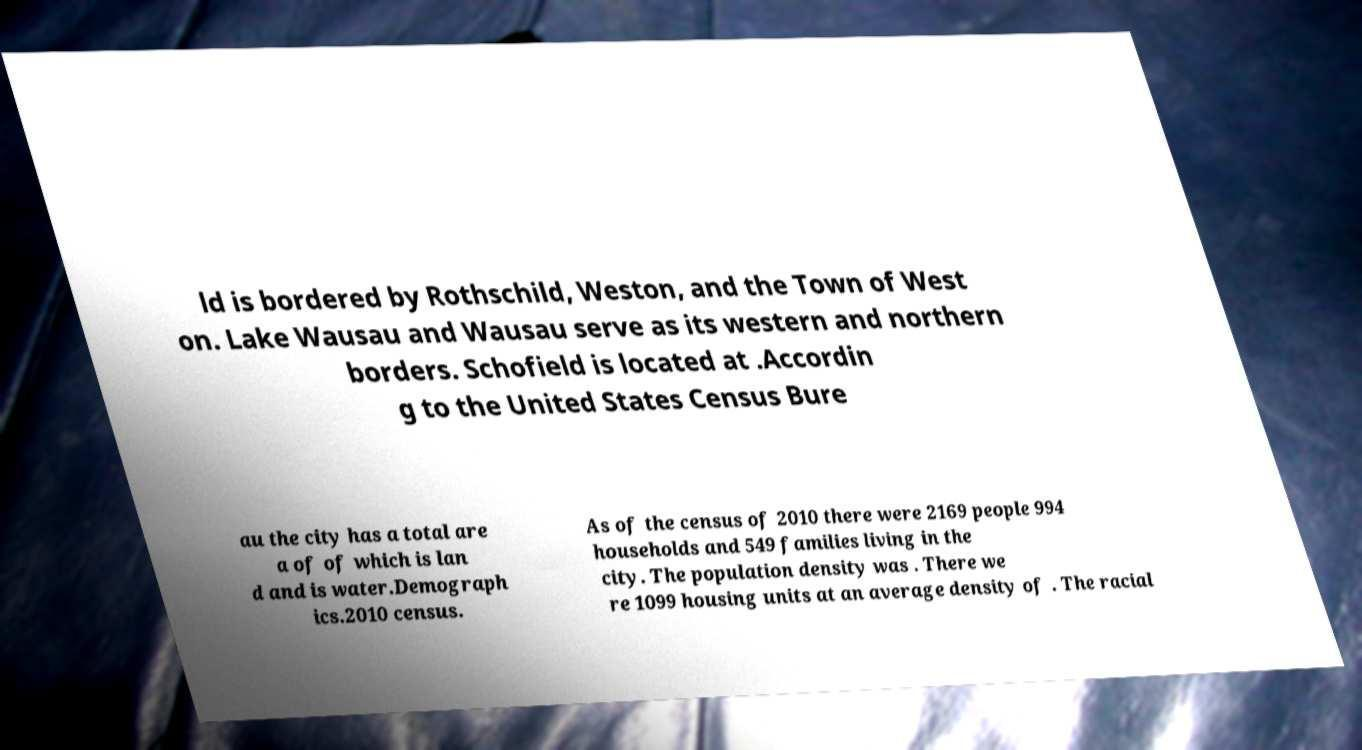For documentation purposes, I need the text within this image transcribed. Could you provide that? ld is bordered by Rothschild, Weston, and the Town of West on. Lake Wausau and Wausau serve as its western and northern borders. Schofield is located at .Accordin g to the United States Census Bure au the city has a total are a of of which is lan d and is water.Demograph ics.2010 census. As of the census of 2010 there were 2169 people 994 households and 549 families living in the city. The population density was . There we re 1099 housing units at an average density of . The racial 